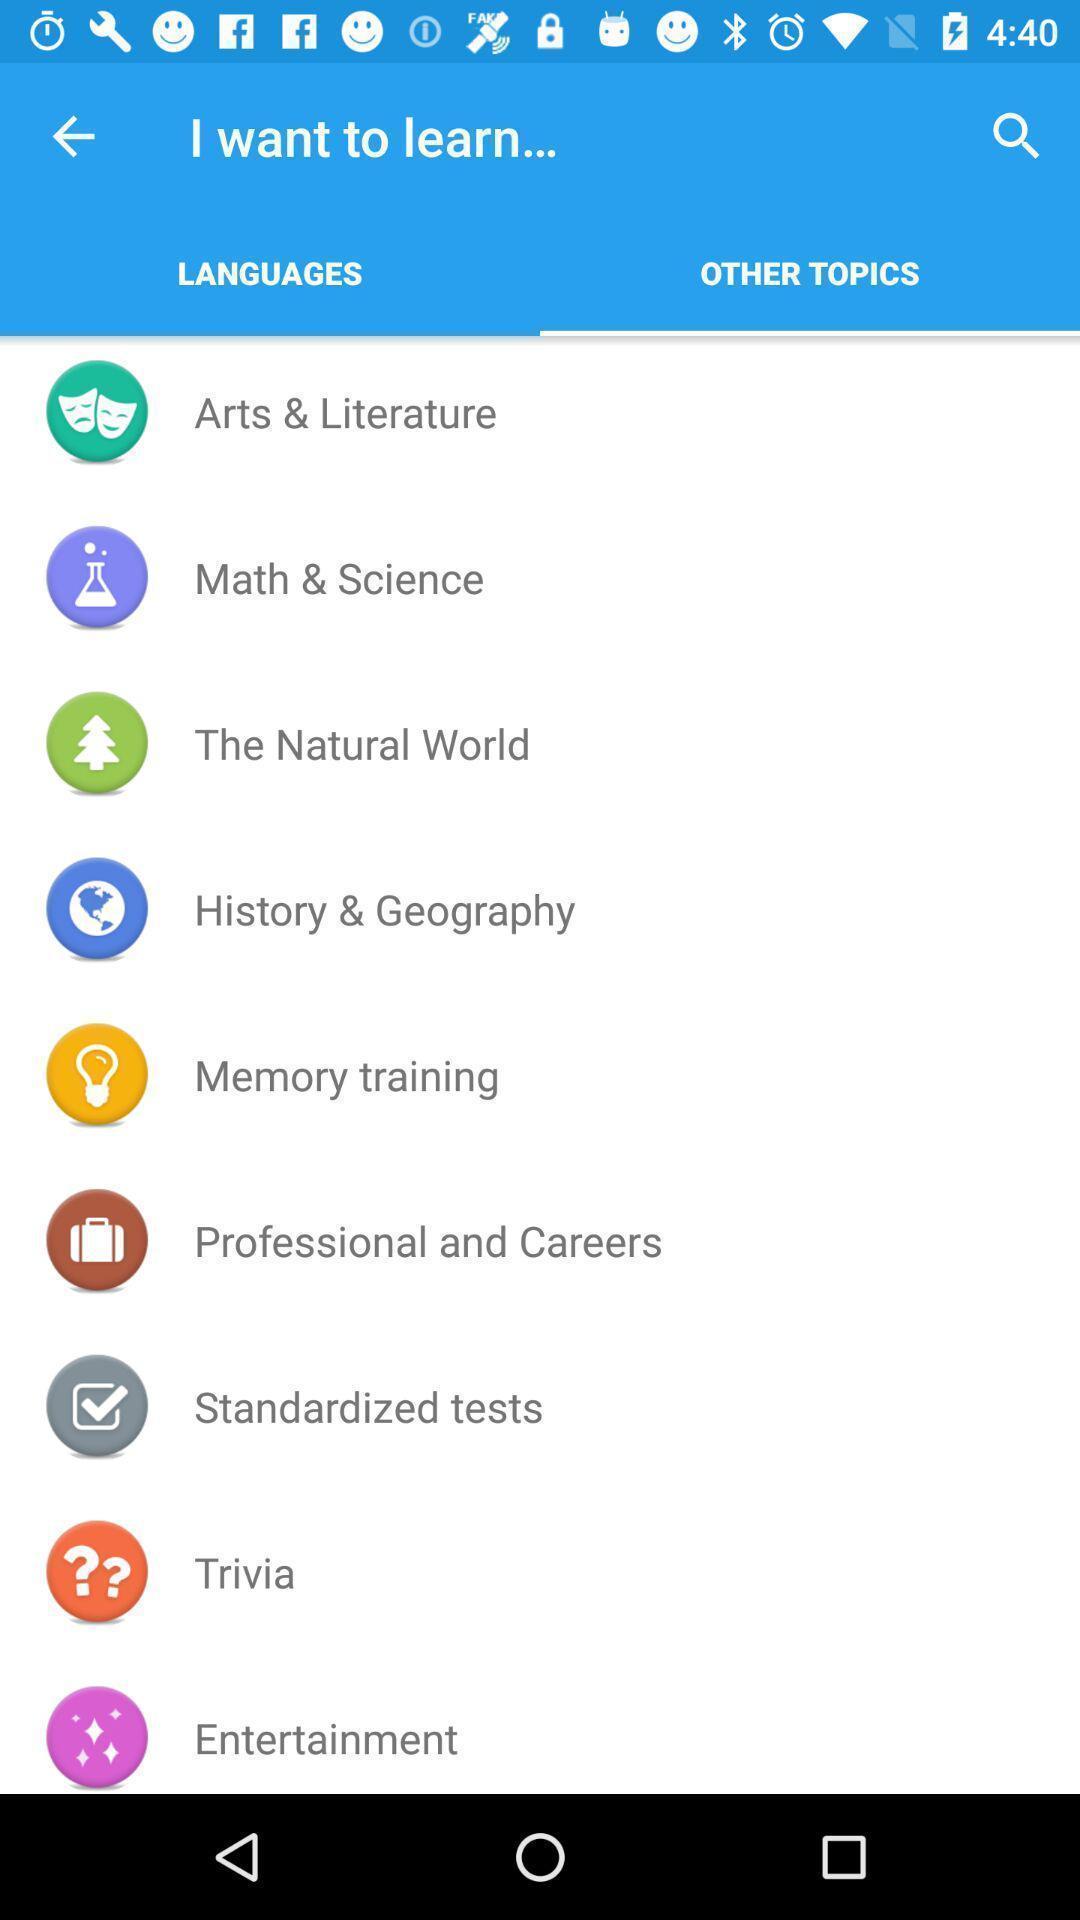Explain what's happening in this screen capture. Page showing various topics in a learning app. 